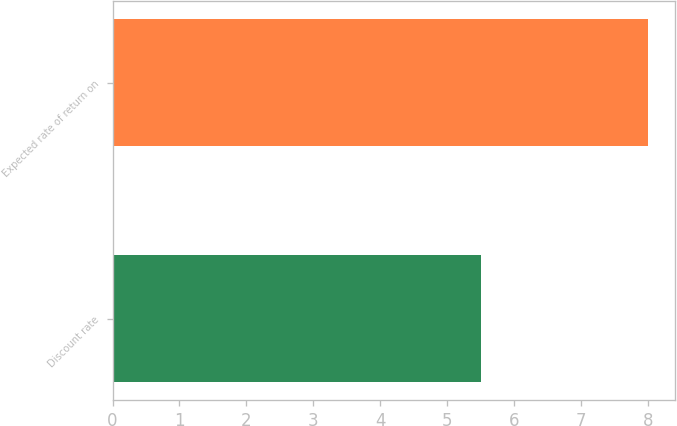Convert chart to OTSL. <chart><loc_0><loc_0><loc_500><loc_500><bar_chart><fcel>Discount rate<fcel>Expected rate of return on<nl><fcel>5.5<fcel>8<nl></chart> 